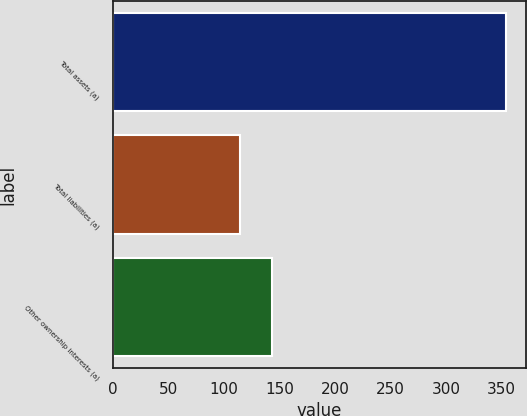Convert chart to OTSL. <chart><loc_0><loc_0><loc_500><loc_500><bar_chart><fcel>Total assets (a)<fcel>Total liabilities (a)<fcel>Other ownership interests (a)<nl><fcel>354<fcel>114<fcel>143<nl></chart> 